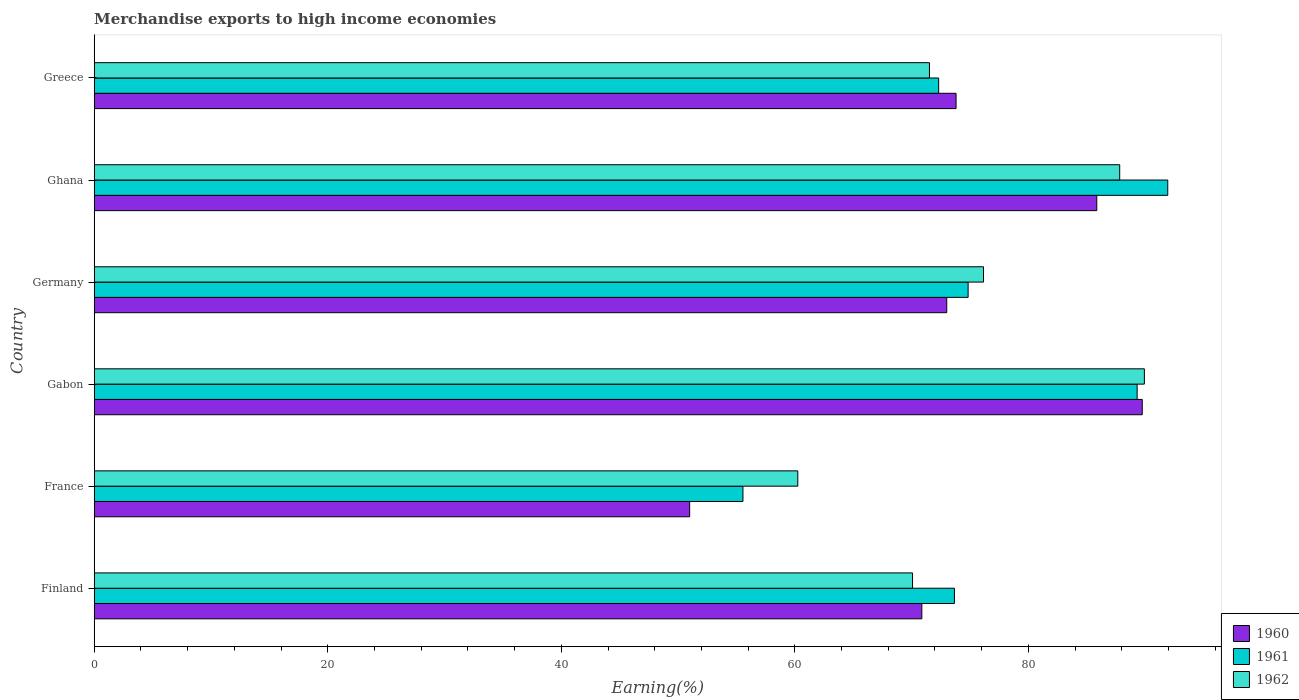Are the number of bars per tick equal to the number of legend labels?
Give a very brief answer. Yes. Are the number of bars on each tick of the Y-axis equal?
Keep it short and to the point. Yes. What is the label of the 6th group of bars from the top?
Offer a very short reply. Finland. In how many cases, is the number of bars for a given country not equal to the number of legend labels?
Give a very brief answer. 0. What is the percentage of amount earned from merchandise exports in 1961 in France?
Keep it short and to the point. 55.56. Across all countries, what is the maximum percentage of amount earned from merchandise exports in 1960?
Your answer should be very brief. 89.75. Across all countries, what is the minimum percentage of amount earned from merchandise exports in 1962?
Provide a short and direct response. 60.25. In which country was the percentage of amount earned from merchandise exports in 1960 maximum?
Offer a terse response. Gabon. In which country was the percentage of amount earned from merchandise exports in 1960 minimum?
Offer a terse response. France. What is the total percentage of amount earned from merchandise exports in 1962 in the graph?
Ensure brevity in your answer.  455.76. What is the difference between the percentage of amount earned from merchandise exports in 1961 in Finland and that in Ghana?
Your answer should be very brief. -18.27. What is the difference between the percentage of amount earned from merchandise exports in 1962 in Greece and the percentage of amount earned from merchandise exports in 1960 in Ghana?
Your response must be concise. -14.33. What is the average percentage of amount earned from merchandise exports in 1961 per country?
Give a very brief answer. 76.27. What is the difference between the percentage of amount earned from merchandise exports in 1961 and percentage of amount earned from merchandise exports in 1962 in Ghana?
Provide a succinct answer. 4.12. What is the ratio of the percentage of amount earned from merchandise exports in 1960 in Finland to that in Greece?
Provide a short and direct response. 0.96. Is the percentage of amount earned from merchandise exports in 1962 in Finland less than that in Gabon?
Offer a very short reply. Yes. What is the difference between the highest and the second highest percentage of amount earned from merchandise exports in 1962?
Ensure brevity in your answer.  2.11. What is the difference between the highest and the lowest percentage of amount earned from merchandise exports in 1960?
Offer a very short reply. 38.76. In how many countries, is the percentage of amount earned from merchandise exports in 1962 greater than the average percentage of amount earned from merchandise exports in 1962 taken over all countries?
Ensure brevity in your answer.  3. What does the 1st bar from the top in Greece represents?
Your answer should be compact. 1962. What does the 1st bar from the bottom in Ghana represents?
Offer a very short reply. 1960. How many countries are there in the graph?
Provide a succinct answer. 6. Are the values on the major ticks of X-axis written in scientific E-notation?
Keep it short and to the point. No. Does the graph contain grids?
Your response must be concise. No. How many legend labels are there?
Make the answer very short. 3. How are the legend labels stacked?
Provide a short and direct response. Vertical. What is the title of the graph?
Your answer should be very brief. Merchandise exports to high income economies. What is the label or title of the X-axis?
Offer a terse response. Earning(%). What is the Earning(%) in 1960 in Finland?
Provide a short and direct response. 70.87. What is the Earning(%) of 1961 in Finland?
Offer a very short reply. 73.67. What is the Earning(%) in 1962 in Finland?
Make the answer very short. 70.08. What is the Earning(%) of 1960 in France?
Your response must be concise. 50.99. What is the Earning(%) of 1961 in France?
Offer a very short reply. 55.56. What is the Earning(%) in 1962 in France?
Offer a very short reply. 60.25. What is the Earning(%) in 1960 in Gabon?
Ensure brevity in your answer.  89.75. What is the Earning(%) of 1961 in Gabon?
Provide a succinct answer. 89.31. What is the Earning(%) of 1962 in Gabon?
Provide a succinct answer. 89.93. What is the Earning(%) in 1960 in Germany?
Your response must be concise. 73.01. What is the Earning(%) in 1961 in Germany?
Provide a short and direct response. 74.84. What is the Earning(%) of 1962 in Germany?
Ensure brevity in your answer.  76.15. What is the Earning(%) of 1960 in Ghana?
Offer a very short reply. 85.85. What is the Earning(%) of 1961 in Ghana?
Make the answer very short. 91.93. What is the Earning(%) of 1962 in Ghana?
Your answer should be compact. 87.82. What is the Earning(%) in 1960 in Greece?
Keep it short and to the point. 73.81. What is the Earning(%) of 1961 in Greece?
Give a very brief answer. 72.31. What is the Earning(%) of 1962 in Greece?
Keep it short and to the point. 71.53. Across all countries, what is the maximum Earning(%) of 1960?
Provide a succinct answer. 89.75. Across all countries, what is the maximum Earning(%) in 1961?
Keep it short and to the point. 91.93. Across all countries, what is the maximum Earning(%) in 1962?
Your answer should be compact. 89.93. Across all countries, what is the minimum Earning(%) in 1960?
Your answer should be very brief. 50.99. Across all countries, what is the minimum Earning(%) in 1961?
Make the answer very short. 55.56. Across all countries, what is the minimum Earning(%) in 1962?
Keep it short and to the point. 60.25. What is the total Earning(%) in 1960 in the graph?
Give a very brief answer. 444.28. What is the total Earning(%) in 1961 in the graph?
Provide a short and direct response. 457.62. What is the total Earning(%) of 1962 in the graph?
Your response must be concise. 455.76. What is the difference between the Earning(%) in 1960 in Finland and that in France?
Keep it short and to the point. 19.88. What is the difference between the Earning(%) of 1961 in Finland and that in France?
Offer a very short reply. 18.11. What is the difference between the Earning(%) in 1962 in Finland and that in France?
Keep it short and to the point. 9.83. What is the difference between the Earning(%) in 1960 in Finland and that in Gabon?
Ensure brevity in your answer.  -18.88. What is the difference between the Earning(%) of 1961 in Finland and that in Gabon?
Offer a very short reply. -15.65. What is the difference between the Earning(%) in 1962 in Finland and that in Gabon?
Your answer should be very brief. -19.85. What is the difference between the Earning(%) of 1960 in Finland and that in Germany?
Ensure brevity in your answer.  -2.13. What is the difference between the Earning(%) of 1961 in Finland and that in Germany?
Keep it short and to the point. -1.17. What is the difference between the Earning(%) in 1962 in Finland and that in Germany?
Your answer should be very brief. -6.08. What is the difference between the Earning(%) in 1960 in Finland and that in Ghana?
Make the answer very short. -14.98. What is the difference between the Earning(%) of 1961 in Finland and that in Ghana?
Keep it short and to the point. -18.27. What is the difference between the Earning(%) in 1962 in Finland and that in Ghana?
Ensure brevity in your answer.  -17.74. What is the difference between the Earning(%) in 1960 in Finland and that in Greece?
Provide a short and direct response. -2.93. What is the difference between the Earning(%) in 1961 in Finland and that in Greece?
Ensure brevity in your answer.  1.35. What is the difference between the Earning(%) in 1962 in Finland and that in Greece?
Offer a very short reply. -1.45. What is the difference between the Earning(%) in 1960 in France and that in Gabon?
Provide a short and direct response. -38.76. What is the difference between the Earning(%) of 1961 in France and that in Gabon?
Provide a short and direct response. -33.76. What is the difference between the Earning(%) in 1962 in France and that in Gabon?
Keep it short and to the point. -29.68. What is the difference between the Earning(%) in 1960 in France and that in Germany?
Provide a succinct answer. -22.02. What is the difference between the Earning(%) in 1961 in France and that in Germany?
Offer a terse response. -19.28. What is the difference between the Earning(%) in 1962 in France and that in Germany?
Your answer should be compact. -15.9. What is the difference between the Earning(%) in 1960 in France and that in Ghana?
Keep it short and to the point. -34.86. What is the difference between the Earning(%) of 1961 in France and that in Ghana?
Offer a terse response. -36.38. What is the difference between the Earning(%) in 1962 in France and that in Ghana?
Give a very brief answer. -27.57. What is the difference between the Earning(%) of 1960 in France and that in Greece?
Provide a succinct answer. -22.81. What is the difference between the Earning(%) in 1961 in France and that in Greece?
Your answer should be very brief. -16.76. What is the difference between the Earning(%) of 1962 in France and that in Greece?
Provide a succinct answer. -11.27. What is the difference between the Earning(%) in 1960 in Gabon and that in Germany?
Your response must be concise. 16.74. What is the difference between the Earning(%) of 1961 in Gabon and that in Germany?
Offer a terse response. 14.47. What is the difference between the Earning(%) in 1962 in Gabon and that in Germany?
Ensure brevity in your answer.  13.78. What is the difference between the Earning(%) of 1960 in Gabon and that in Ghana?
Give a very brief answer. 3.89. What is the difference between the Earning(%) of 1961 in Gabon and that in Ghana?
Provide a short and direct response. -2.62. What is the difference between the Earning(%) of 1962 in Gabon and that in Ghana?
Your answer should be very brief. 2.11. What is the difference between the Earning(%) of 1960 in Gabon and that in Greece?
Your response must be concise. 15.94. What is the difference between the Earning(%) in 1961 in Gabon and that in Greece?
Offer a terse response. 17. What is the difference between the Earning(%) of 1962 in Gabon and that in Greece?
Provide a short and direct response. 18.41. What is the difference between the Earning(%) in 1960 in Germany and that in Ghana?
Provide a short and direct response. -12.85. What is the difference between the Earning(%) in 1961 in Germany and that in Ghana?
Your answer should be compact. -17.09. What is the difference between the Earning(%) in 1962 in Germany and that in Ghana?
Ensure brevity in your answer.  -11.66. What is the difference between the Earning(%) in 1960 in Germany and that in Greece?
Your answer should be compact. -0.8. What is the difference between the Earning(%) of 1961 in Germany and that in Greece?
Your answer should be compact. 2.52. What is the difference between the Earning(%) in 1962 in Germany and that in Greece?
Make the answer very short. 4.63. What is the difference between the Earning(%) of 1960 in Ghana and that in Greece?
Provide a short and direct response. 12.05. What is the difference between the Earning(%) in 1961 in Ghana and that in Greece?
Provide a succinct answer. 19.62. What is the difference between the Earning(%) in 1962 in Ghana and that in Greece?
Provide a succinct answer. 16.29. What is the difference between the Earning(%) of 1960 in Finland and the Earning(%) of 1961 in France?
Provide a succinct answer. 15.32. What is the difference between the Earning(%) of 1960 in Finland and the Earning(%) of 1962 in France?
Your answer should be compact. 10.62. What is the difference between the Earning(%) in 1961 in Finland and the Earning(%) in 1962 in France?
Provide a short and direct response. 13.41. What is the difference between the Earning(%) of 1960 in Finland and the Earning(%) of 1961 in Gabon?
Provide a short and direct response. -18.44. What is the difference between the Earning(%) in 1960 in Finland and the Earning(%) in 1962 in Gabon?
Offer a terse response. -19.06. What is the difference between the Earning(%) in 1961 in Finland and the Earning(%) in 1962 in Gabon?
Offer a very short reply. -16.27. What is the difference between the Earning(%) in 1960 in Finland and the Earning(%) in 1961 in Germany?
Give a very brief answer. -3.96. What is the difference between the Earning(%) of 1960 in Finland and the Earning(%) of 1962 in Germany?
Offer a terse response. -5.28. What is the difference between the Earning(%) of 1961 in Finland and the Earning(%) of 1962 in Germany?
Your answer should be compact. -2.49. What is the difference between the Earning(%) in 1960 in Finland and the Earning(%) in 1961 in Ghana?
Your answer should be very brief. -21.06. What is the difference between the Earning(%) of 1960 in Finland and the Earning(%) of 1962 in Ghana?
Your answer should be compact. -16.94. What is the difference between the Earning(%) in 1961 in Finland and the Earning(%) in 1962 in Ghana?
Offer a very short reply. -14.15. What is the difference between the Earning(%) of 1960 in Finland and the Earning(%) of 1961 in Greece?
Provide a succinct answer. -1.44. What is the difference between the Earning(%) in 1960 in Finland and the Earning(%) in 1962 in Greece?
Ensure brevity in your answer.  -0.65. What is the difference between the Earning(%) in 1961 in Finland and the Earning(%) in 1962 in Greece?
Ensure brevity in your answer.  2.14. What is the difference between the Earning(%) in 1960 in France and the Earning(%) in 1961 in Gabon?
Your answer should be compact. -38.32. What is the difference between the Earning(%) in 1960 in France and the Earning(%) in 1962 in Gabon?
Your answer should be very brief. -38.94. What is the difference between the Earning(%) of 1961 in France and the Earning(%) of 1962 in Gabon?
Your answer should be very brief. -34.38. What is the difference between the Earning(%) in 1960 in France and the Earning(%) in 1961 in Germany?
Offer a very short reply. -23.85. What is the difference between the Earning(%) of 1960 in France and the Earning(%) of 1962 in Germany?
Provide a short and direct response. -25.16. What is the difference between the Earning(%) of 1961 in France and the Earning(%) of 1962 in Germany?
Ensure brevity in your answer.  -20.6. What is the difference between the Earning(%) in 1960 in France and the Earning(%) in 1961 in Ghana?
Offer a very short reply. -40.94. What is the difference between the Earning(%) in 1960 in France and the Earning(%) in 1962 in Ghana?
Your answer should be compact. -36.83. What is the difference between the Earning(%) of 1961 in France and the Earning(%) of 1962 in Ghana?
Provide a succinct answer. -32.26. What is the difference between the Earning(%) of 1960 in France and the Earning(%) of 1961 in Greece?
Provide a short and direct response. -21.32. What is the difference between the Earning(%) of 1960 in France and the Earning(%) of 1962 in Greece?
Your answer should be compact. -20.54. What is the difference between the Earning(%) of 1961 in France and the Earning(%) of 1962 in Greece?
Make the answer very short. -15.97. What is the difference between the Earning(%) in 1960 in Gabon and the Earning(%) in 1961 in Germany?
Offer a very short reply. 14.91. What is the difference between the Earning(%) in 1960 in Gabon and the Earning(%) in 1962 in Germany?
Offer a terse response. 13.59. What is the difference between the Earning(%) in 1961 in Gabon and the Earning(%) in 1962 in Germany?
Provide a succinct answer. 13.16. What is the difference between the Earning(%) in 1960 in Gabon and the Earning(%) in 1961 in Ghana?
Give a very brief answer. -2.18. What is the difference between the Earning(%) of 1960 in Gabon and the Earning(%) of 1962 in Ghana?
Offer a terse response. 1.93. What is the difference between the Earning(%) in 1961 in Gabon and the Earning(%) in 1962 in Ghana?
Keep it short and to the point. 1.49. What is the difference between the Earning(%) of 1960 in Gabon and the Earning(%) of 1961 in Greece?
Your response must be concise. 17.43. What is the difference between the Earning(%) in 1960 in Gabon and the Earning(%) in 1962 in Greece?
Offer a terse response. 18.22. What is the difference between the Earning(%) in 1961 in Gabon and the Earning(%) in 1962 in Greece?
Provide a succinct answer. 17.79. What is the difference between the Earning(%) in 1960 in Germany and the Earning(%) in 1961 in Ghana?
Offer a terse response. -18.93. What is the difference between the Earning(%) in 1960 in Germany and the Earning(%) in 1962 in Ghana?
Keep it short and to the point. -14.81. What is the difference between the Earning(%) in 1961 in Germany and the Earning(%) in 1962 in Ghana?
Offer a very short reply. -12.98. What is the difference between the Earning(%) of 1960 in Germany and the Earning(%) of 1961 in Greece?
Provide a succinct answer. 0.69. What is the difference between the Earning(%) of 1960 in Germany and the Earning(%) of 1962 in Greece?
Offer a very short reply. 1.48. What is the difference between the Earning(%) of 1961 in Germany and the Earning(%) of 1962 in Greece?
Offer a terse response. 3.31. What is the difference between the Earning(%) of 1960 in Ghana and the Earning(%) of 1961 in Greece?
Provide a short and direct response. 13.54. What is the difference between the Earning(%) in 1960 in Ghana and the Earning(%) in 1962 in Greece?
Offer a terse response. 14.33. What is the difference between the Earning(%) in 1961 in Ghana and the Earning(%) in 1962 in Greece?
Offer a very short reply. 20.41. What is the average Earning(%) in 1960 per country?
Offer a very short reply. 74.05. What is the average Earning(%) of 1961 per country?
Your answer should be very brief. 76.27. What is the average Earning(%) of 1962 per country?
Your answer should be very brief. 75.96. What is the difference between the Earning(%) in 1960 and Earning(%) in 1961 in Finland?
Your answer should be compact. -2.79. What is the difference between the Earning(%) in 1960 and Earning(%) in 1962 in Finland?
Your response must be concise. 0.79. What is the difference between the Earning(%) of 1961 and Earning(%) of 1962 in Finland?
Make the answer very short. 3.59. What is the difference between the Earning(%) in 1960 and Earning(%) in 1961 in France?
Offer a terse response. -4.56. What is the difference between the Earning(%) in 1960 and Earning(%) in 1962 in France?
Provide a short and direct response. -9.26. What is the difference between the Earning(%) in 1961 and Earning(%) in 1962 in France?
Make the answer very short. -4.7. What is the difference between the Earning(%) in 1960 and Earning(%) in 1961 in Gabon?
Keep it short and to the point. 0.44. What is the difference between the Earning(%) in 1960 and Earning(%) in 1962 in Gabon?
Give a very brief answer. -0.18. What is the difference between the Earning(%) in 1961 and Earning(%) in 1962 in Gabon?
Keep it short and to the point. -0.62. What is the difference between the Earning(%) of 1960 and Earning(%) of 1961 in Germany?
Provide a succinct answer. -1.83. What is the difference between the Earning(%) of 1960 and Earning(%) of 1962 in Germany?
Offer a terse response. -3.15. What is the difference between the Earning(%) in 1961 and Earning(%) in 1962 in Germany?
Give a very brief answer. -1.32. What is the difference between the Earning(%) of 1960 and Earning(%) of 1961 in Ghana?
Your answer should be very brief. -6.08. What is the difference between the Earning(%) in 1960 and Earning(%) in 1962 in Ghana?
Your answer should be very brief. -1.96. What is the difference between the Earning(%) of 1961 and Earning(%) of 1962 in Ghana?
Offer a terse response. 4.12. What is the difference between the Earning(%) in 1960 and Earning(%) in 1961 in Greece?
Your answer should be compact. 1.49. What is the difference between the Earning(%) in 1960 and Earning(%) in 1962 in Greece?
Your response must be concise. 2.28. What is the difference between the Earning(%) in 1961 and Earning(%) in 1962 in Greece?
Offer a very short reply. 0.79. What is the ratio of the Earning(%) in 1960 in Finland to that in France?
Your response must be concise. 1.39. What is the ratio of the Earning(%) in 1961 in Finland to that in France?
Keep it short and to the point. 1.33. What is the ratio of the Earning(%) in 1962 in Finland to that in France?
Give a very brief answer. 1.16. What is the ratio of the Earning(%) of 1960 in Finland to that in Gabon?
Provide a succinct answer. 0.79. What is the ratio of the Earning(%) of 1961 in Finland to that in Gabon?
Provide a succinct answer. 0.82. What is the ratio of the Earning(%) of 1962 in Finland to that in Gabon?
Keep it short and to the point. 0.78. What is the ratio of the Earning(%) of 1960 in Finland to that in Germany?
Your answer should be compact. 0.97. What is the ratio of the Earning(%) of 1961 in Finland to that in Germany?
Make the answer very short. 0.98. What is the ratio of the Earning(%) of 1962 in Finland to that in Germany?
Provide a succinct answer. 0.92. What is the ratio of the Earning(%) of 1960 in Finland to that in Ghana?
Give a very brief answer. 0.83. What is the ratio of the Earning(%) of 1961 in Finland to that in Ghana?
Make the answer very short. 0.8. What is the ratio of the Earning(%) of 1962 in Finland to that in Ghana?
Offer a very short reply. 0.8. What is the ratio of the Earning(%) in 1960 in Finland to that in Greece?
Keep it short and to the point. 0.96. What is the ratio of the Earning(%) of 1961 in Finland to that in Greece?
Make the answer very short. 1.02. What is the ratio of the Earning(%) in 1962 in Finland to that in Greece?
Ensure brevity in your answer.  0.98. What is the ratio of the Earning(%) in 1960 in France to that in Gabon?
Your response must be concise. 0.57. What is the ratio of the Earning(%) in 1961 in France to that in Gabon?
Ensure brevity in your answer.  0.62. What is the ratio of the Earning(%) of 1962 in France to that in Gabon?
Give a very brief answer. 0.67. What is the ratio of the Earning(%) of 1960 in France to that in Germany?
Your answer should be very brief. 0.7. What is the ratio of the Earning(%) of 1961 in France to that in Germany?
Give a very brief answer. 0.74. What is the ratio of the Earning(%) in 1962 in France to that in Germany?
Give a very brief answer. 0.79. What is the ratio of the Earning(%) in 1960 in France to that in Ghana?
Keep it short and to the point. 0.59. What is the ratio of the Earning(%) of 1961 in France to that in Ghana?
Offer a very short reply. 0.6. What is the ratio of the Earning(%) of 1962 in France to that in Ghana?
Give a very brief answer. 0.69. What is the ratio of the Earning(%) in 1960 in France to that in Greece?
Give a very brief answer. 0.69. What is the ratio of the Earning(%) in 1961 in France to that in Greece?
Provide a short and direct response. 0.77. What is the ratio of the Earning(%) in 1962 in France to that in Greece?
Your answer should be compact. 0.84. What is the ratio of the Earning(%) of 1960 in Gabon to that in Germany?
Your answer should be compact. 1.23. What is the ratio of the Earning(%) of 1961 in Gabon to that in Germany?
Provide a succinct answer. 1.19. What is the ratio of the Earning(%) of 1962 in Gabon to that in Germany?
Ensure brevity in your answer.  1.18. What is the ratio of the Earning(%) in 1960 in Gabon to that in Ghana?
Offer a very short reply. 1.05. What is the ratio of the Earning(%) of 1961 in Gabon to that in Ghana?
Your response must be concise. 0.97. What is the ratio of the Earning(%) of 1962 in Gabon to that in Ghana?
Your answer should be compact. 1.02. What is the ratio of the Earning(%) in 1960 in Gabon to that in Greece?
Your answer should be very brief. 1.22. What is the ratio of the Earning(%) of 1961 in Gabon to that in Greece?
Your answer should be compact. 1.24. What is the ratio of the Earning(%) in 1962 in Gabon to that in Greece?
Give a very brief answer. 1.26. What is the ratio of the Earning(%) in 1960 in Germany to that in Ghana?
Offer a very short reply. 0.85. What is the ratio of the Earning(%) of 1961 in Germany to that in Ghana?
Offer a very short reply. 0.81. What is the ratio of the Earning(%) of 1962 in Germany to that in Ghana?
Your response must be concise. 0.87. What is the ratio of the Earning(%) in 1960 in Germany to that in Greece?
Your answer should be compact. 0.99. What is the ratio of the Earning(%) in 1961 in Germany to that in Greece?
Ensure brevity in your answer.  1.03. What is the ratio of the Earning(%) of 1962 in Germany to that in Greece?
Offer a terse response. 1.06. What is the ratio of the Earning(%) in 1960 in Ghana to that in Greece?
Make the answer very short. 1.16. What is the ratio of the Earning(%) of 1961 in Ghana to that in Greece?
Your response must be concise. 1.27. What is the ratio of the Earning(%) of 1962 in Ghana to that in Greece?
Provide a short and direct response. 1.23. What is the difference between the highest and the second highest Earning(%) in 1960?
Your answer should be compact. 3.89. What is the difference between the highest and the second highest Earning(%) of 1961?
Ensure brevity in your answer.  2.62. What is the difference between the highest and the second highest Earning(%) in 1962?
Provide a short and direct response. 2.11. What is the difference between the highest and the lowest Earning(%) of 1960?
Ensure brevity in your answer.  38.76. What is the difference between the highest and the lowest Earning(%) in 1961?
Give a very brief answer. 36.38. What is the difference between the highest and the lowest Earning(%) of 1962?
Offer a terse response. 29.68. 